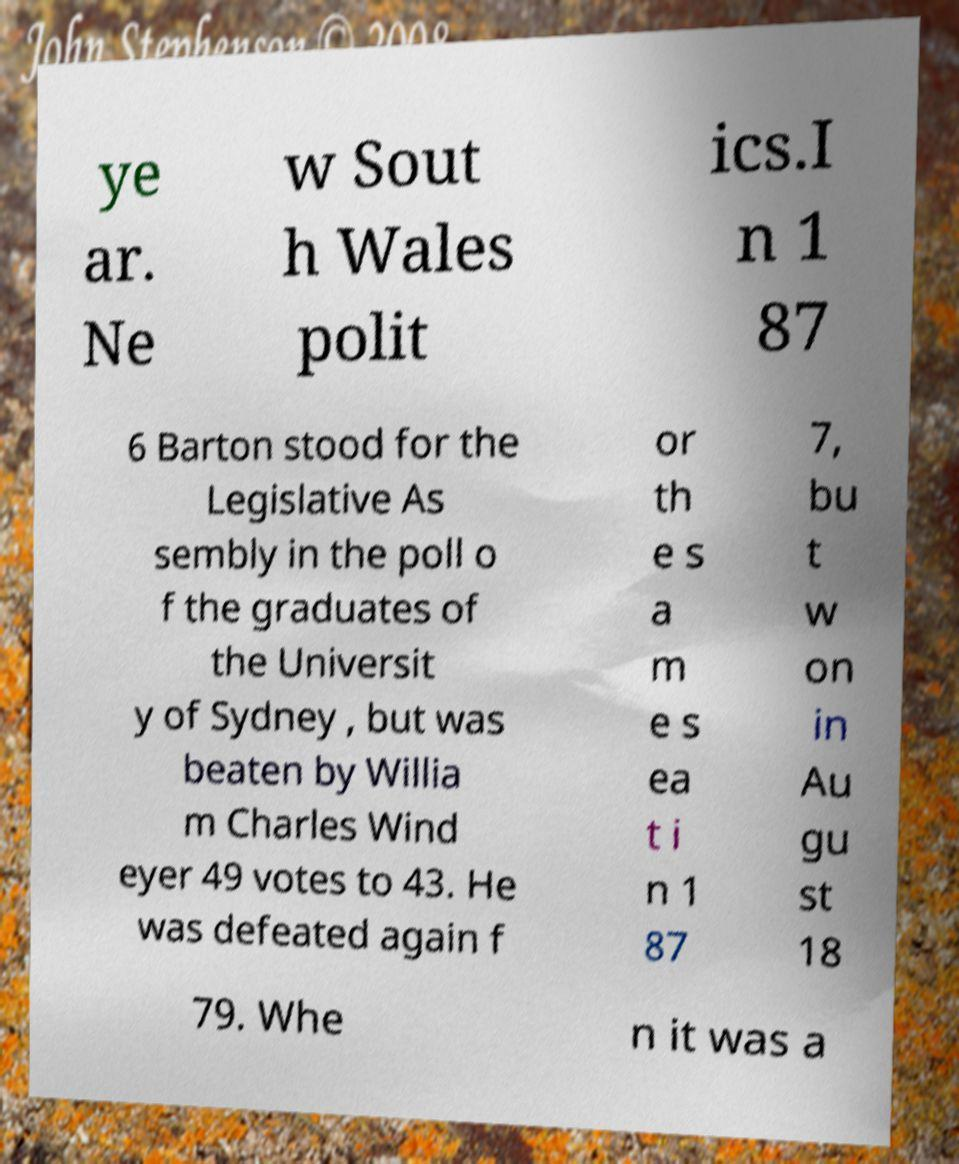There's text embedded in this image that I need extracted. Can you transcribe it verbatim? ye ar. Ne w Sout h Wales polit ics.I n 1 87 6 Barton stood for the Legislative As sembly in the poll o f the graduates of the Universit y of Sydney , but was beaten by Willia m Charles Wind eyer 49 votes to 43. He was defeated again f or th e s a m e s ea t i n 1 87 7, bu t w on in Au gu st 18 79. Whe n it was a 